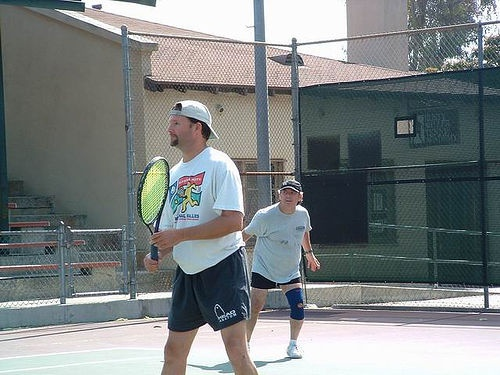Describe the objects in this image and their specific colors. I can see people in darkblue, black, gray, and darkgray tones, people in darkblue, darkgray, gray, and black tones, tennis racket in darkblue, khaki, lightgreen, black, and gray tones, bench in darkblue, gray, darkgray, and black tones, and bench in darkblue, gray, white, and darkgray tones in this image. 